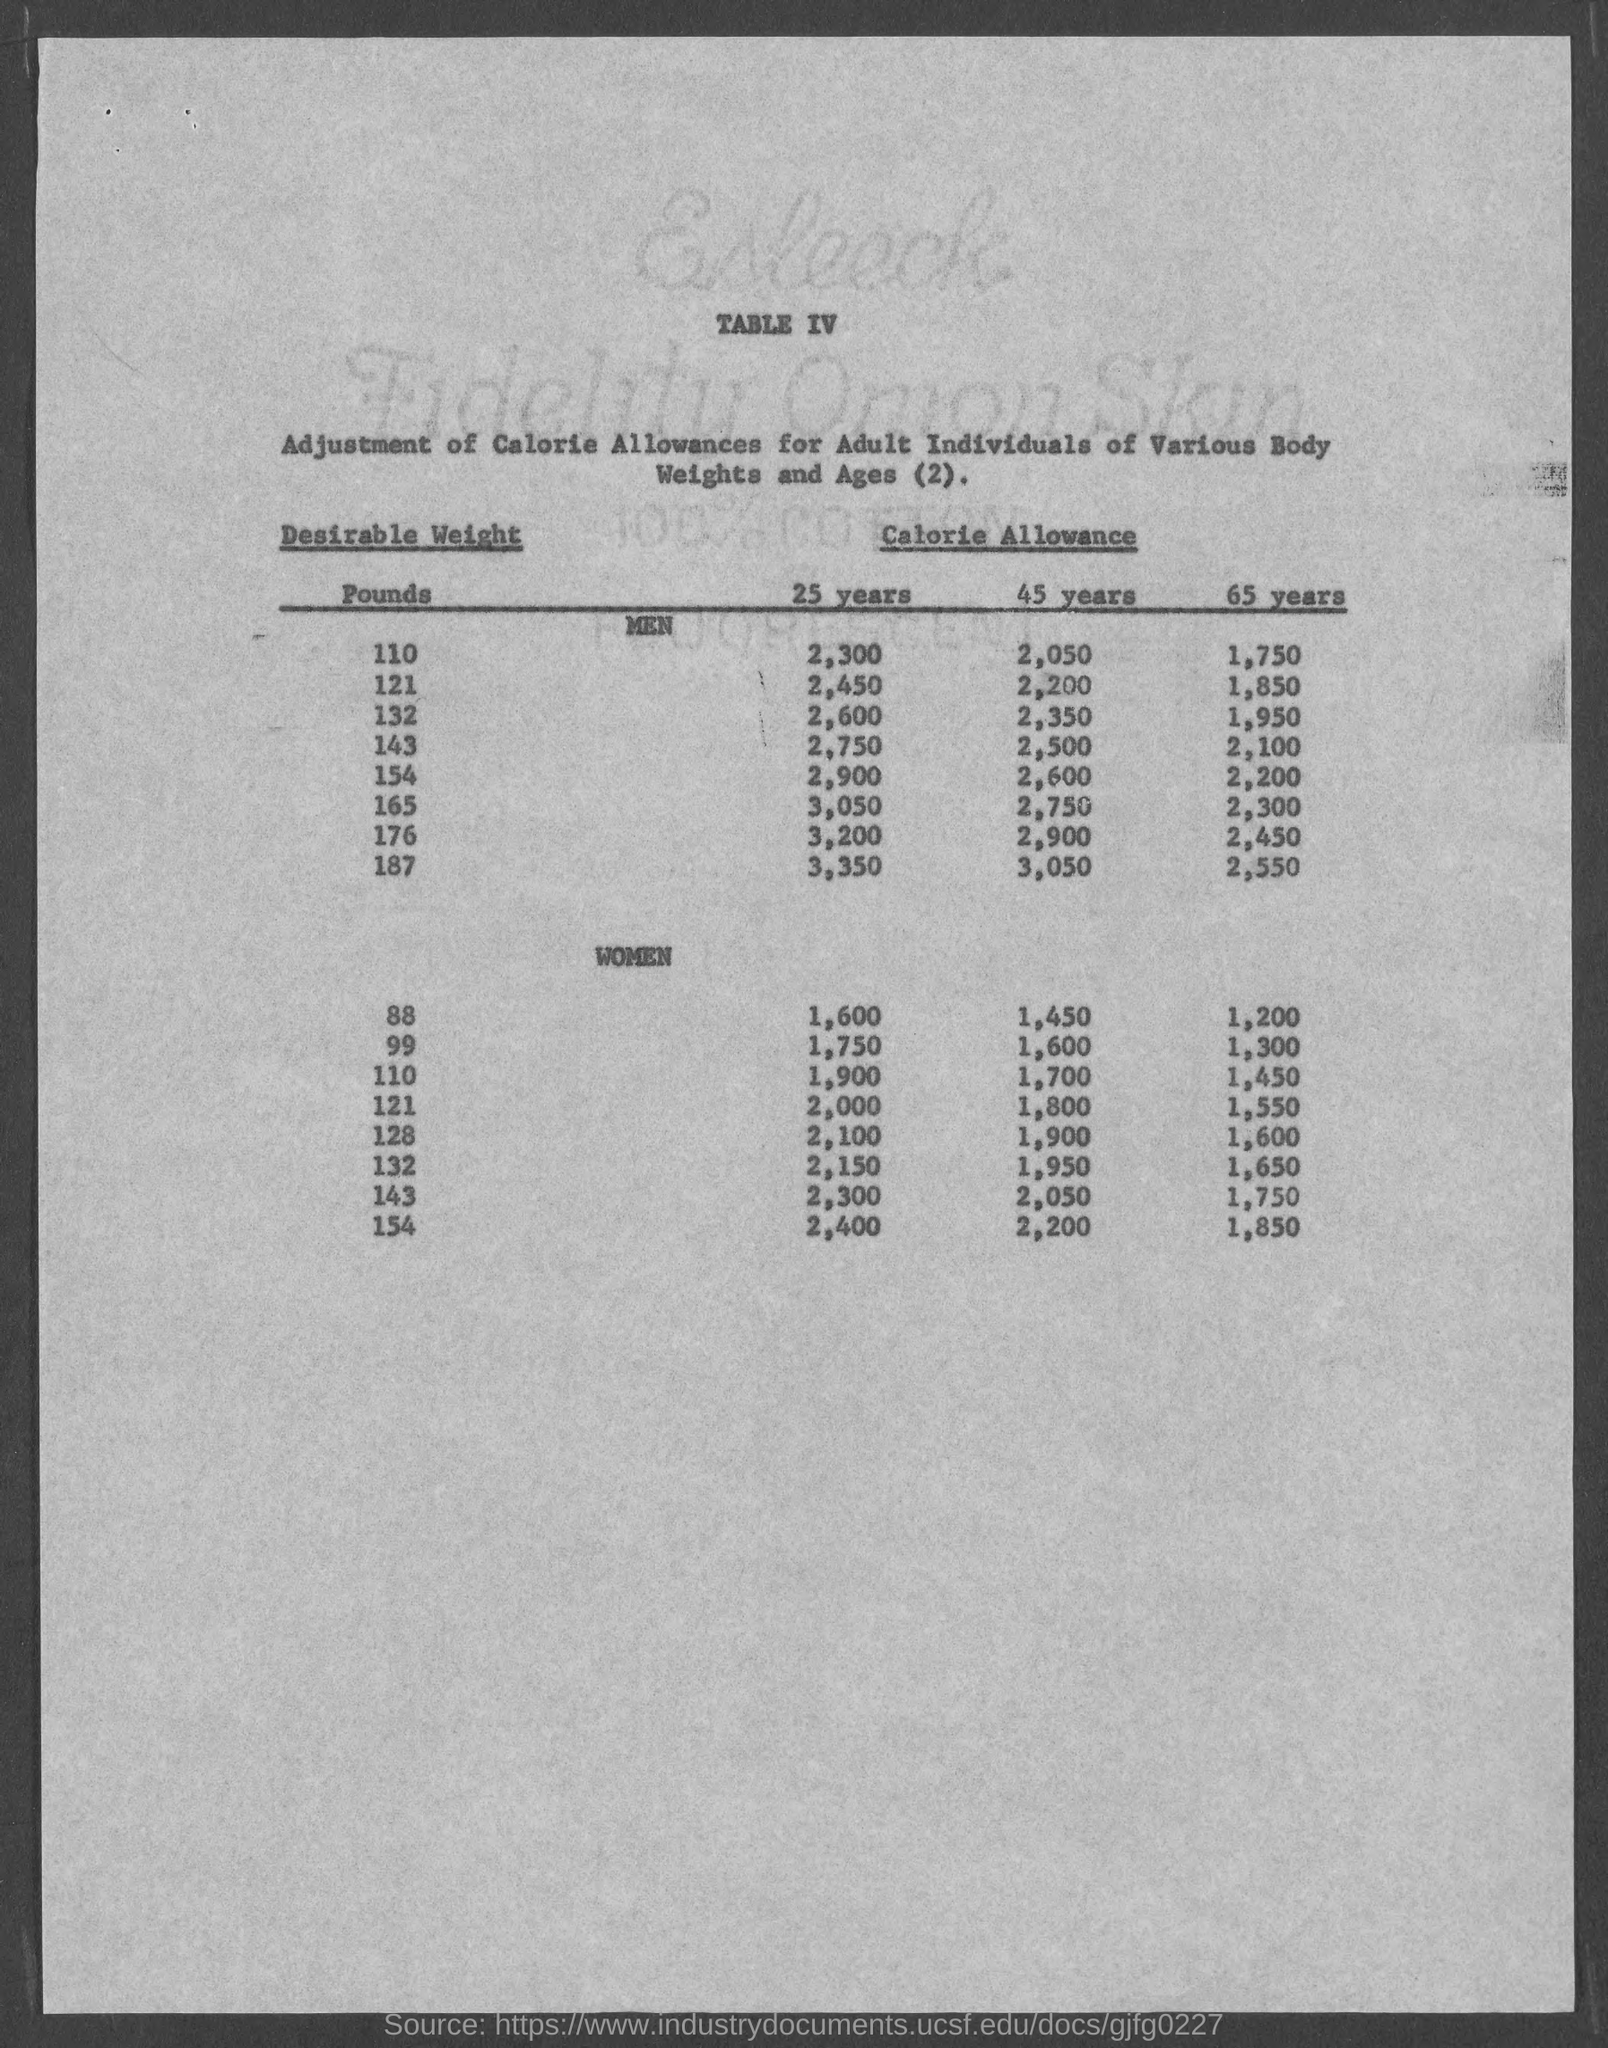Give some essential details in this illustration. The table number is IV.. A daily calorie allowance of 2,050 is recommended for a man who is 45 years old and seeking to maintain a desirable weight of 110 pounds. The recommended daily calorie intake for a man who wishes to maintain a desirable weight of 121 pounds over a 25-year period is approximately 2,450 calories per day. A desirable weight of 165 pounds for a male requires a daily calorie allowance of 3,050 calories. The recommended daily calorie allowance for a 25-year-old man looking to maintain a desirable weight of 110 pounds is 2,300 calories. 